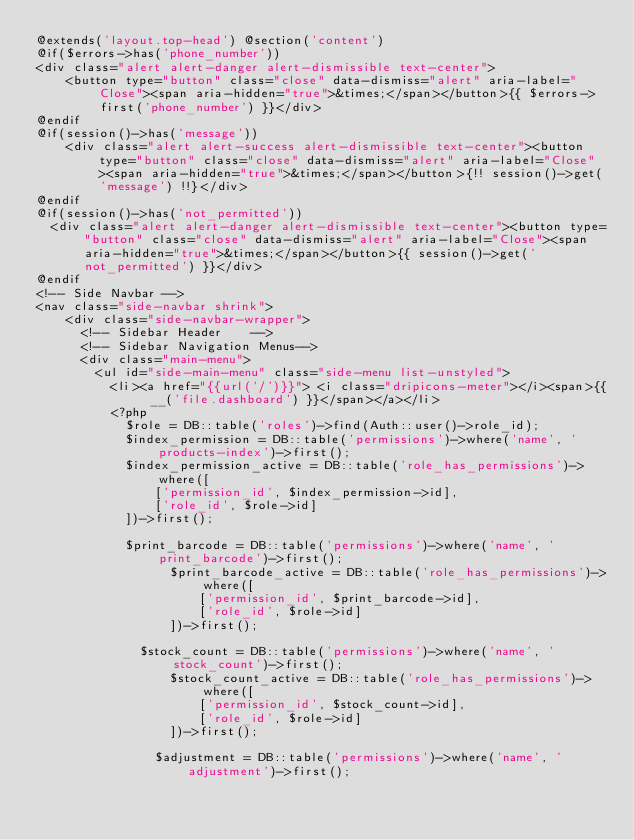Convert code to text. <code><loc_0><loc_0><loc_500><loc_500><_PHP_>@extends('layout.top-head') @section('content')
@if($errors->has('phone_number'))
<div class="alert alert-danger alert-dismissible text-center">
    <button type="button" class="close" data-dismiss="alert" aria-label="Close"><span aria-hidden="true">&times;</span></button>{{ $errors->first('phone_number') }}</div>
@endif
@if(session()->has('message'))
    <div class="alert alert-success alert-dismissible text-center"><button type="button" class="close" data-dismiss="alert" aria-label="Close"><span aria-hidden="true">&times;</span></button>{!! session()->get('message') !!}</div> 
@endif
@if(session()->has('not_permitted'))
  <div class="alert alert-danger alert-dismissible text-center"><button type="button" class="close" data-dismiss="alert" aria-label="Close"><span aria-hidden="true">&times;</span></button>{{ session()->get('not_permitted') }}</div> 
@endif
<!-- Side Navbar -->
<nav class="side-navbar shrink">
    <div class="side-navbar-wrapper">
      <!-- Sidebar Header    -->
      <!-- Sidebar Navigation Menus-->
      <div class="main-menu">
        <ul id="side-main-menu" class="side-menu list-unstyled">                  
          <li><a href="{{url('/')}}"> <i class="dripicons-meter"></i><span>{{ __('file.dashboard') }}</span></a></li>
          <?php
            $role = DB::table('roles')->find(Auth::user()->role_id);
            $index_permission = DB::table('permissions')->where('name', 'products-index')->first();
            $index_permission_active = DB::table('role_has_permissions')->where([
                ['permission_id', $index_permission->id],
                ['role_id', $role->id]
            ])->first();

            $print_barcode = DB::table('permissions')->where('name', 'print_barcode')->first();
                  $print_barcode_active = DB::table('role_has_permissions')->where([
                      ['permission_id', $print_barcode->id],
                      ['role_id', $role->id]
                  ])->first();

              $stock_count = DB::table('permissions')->where('name', 'stock_count')->first();
                  $stock_count_active = DB::table('role_has_permissions')->where([
                      ['permission_id', $stock_count->id],
                      ['role_id', $role->id]
                  ])->first();

                $adjustment = DB::table('permissions')->where('name', 'adjustment')->first();</code> 